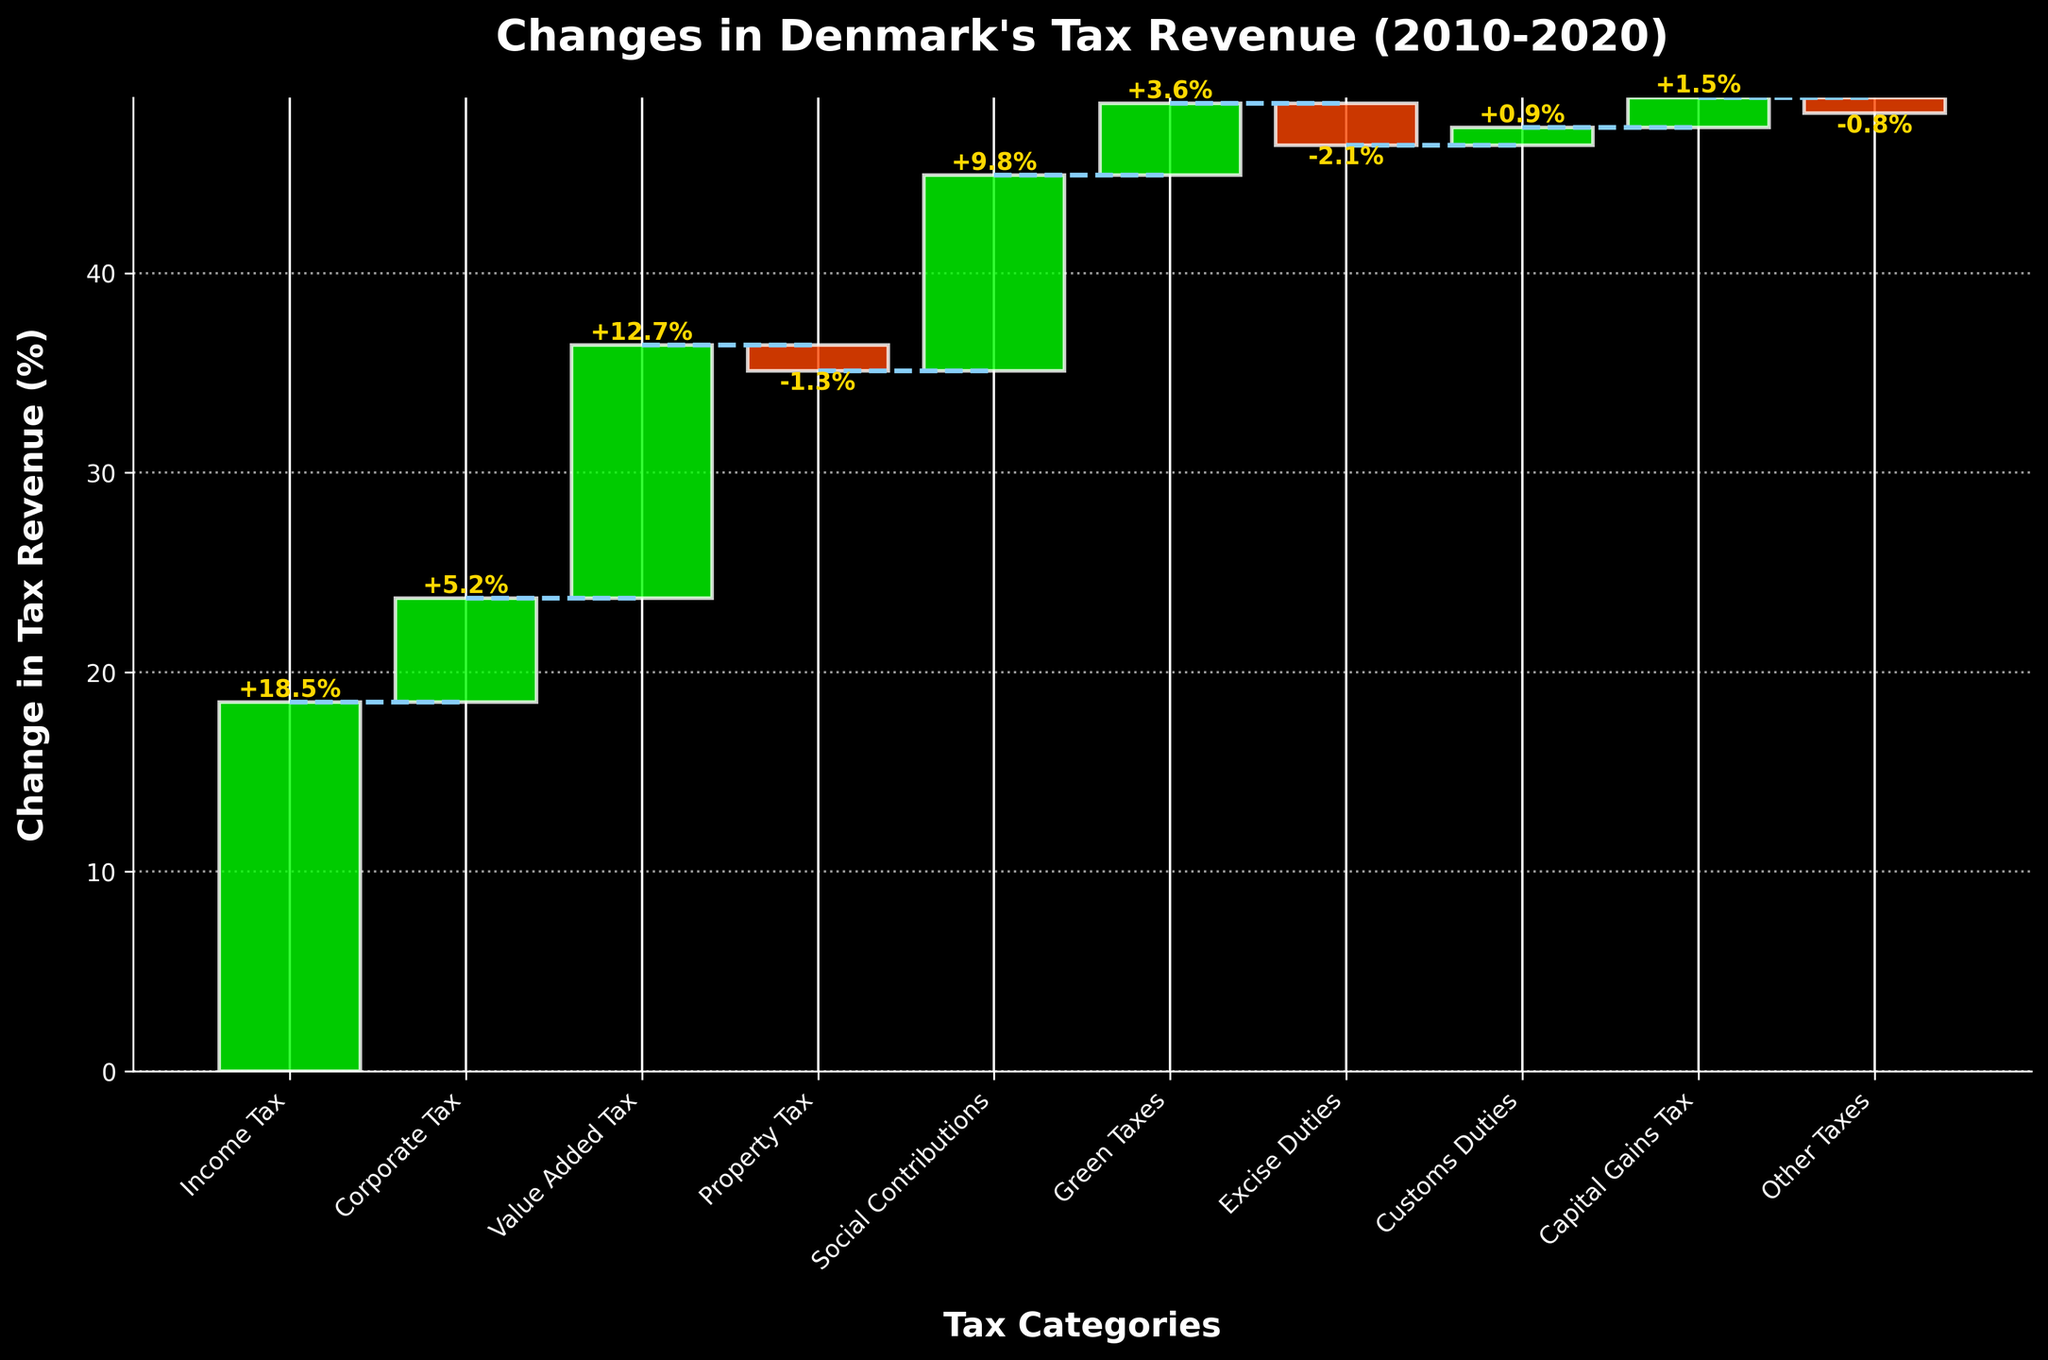What's the title of the figure? The title of a figure is generally placed at the top. In this case, looking at the title at the top of the waterfall chart, we see it is "Changes in Denmark's Tax Revenue (2010-2020)"
Answer: Changes in Denmark's Tax Revenue (2010-2020) Which tax category had the most significant positive change? To determine the most significant positive change, we look for the category with the tallest green bar extending upwards from the previous point. In this figure, the "Income Tax" category shows the most significant positive change of +18.5%.
Answer: Income Tax Which tax category experienced a decrease in tax revenue? The categories with a decrease are represented by red bars. From the figure, "Property Tax," "Excise Duties," and "Other Taxes" have red bars, indicating a decrease. The values are -1.3%, -2.1%, and -0.8% respectively.
Answer: Property Tax, Excise Duties, Other Taxes What's the overall cumulative change by the end of the last category? We sum the values of all categories: +18.5 + 5.2 + 12.7 - 1.3 + 9.8 + 3.6 - 2.1 + 0.9 + 1.5 - 0.8 = +48.0%. Therefore, the overall cumulative change by the end is +48.0%.
Answer: +48.0% Which category showed a minor positive change, and what was its value? To find minor positive changes, we identify the shortest green bar among the positive ones. From the figure, "Capital Gains Tax" shows the smallest positive change with a value of +1.5%.
Answer: Capital Gains Tax, +1.5% Compare the changes in Income Tax and Corporate Tax. Which one had a greater change? To compare, look at the heights of the green bars for "Income Tax" and "Corporate Tax." The "Income Tax" bar (+18.5%) is taller than the "Corporate Tax" bar (+5.2%).
Answer: Income Tax had a greater change What is the combined change in Value Added Tax and Social Contributions? Sum the values of the respective categories: Value Added Tax (+12.7%) and Social Contributions (+9.8%). 12.7 + 9.8 = +22.5%.
Answer: +22.5% What is the change in revenue in Customs Duties? Identify the bar corresponding to Customs Duties, as the value is indicated at the top. Customs Duties show a change of +0.9%.
Answer: +0.9% How many categories showed a positive change in tax revenue? Count the number of green bars in the waterfall chart to determine the number of categories with positive changes. Here, there are 7 green bars: Income Tax, Corporate Tax, Value Added Tax, Social Contributions, Green Taxes, Customs Duties, and Capital Gains Tax.
Answer: 7 Which category saw a more significant decrease: Property Tax or Excise Duties? Compare the heights of the red bars for "Property Tax" and "Excise Duties." The "Excise Duties" bar (-2.1%) is taller than the "Property Tax" bar (-1.3%), indicating a more significant decrease in "Excise Duties."
Answer: Excise Duties 